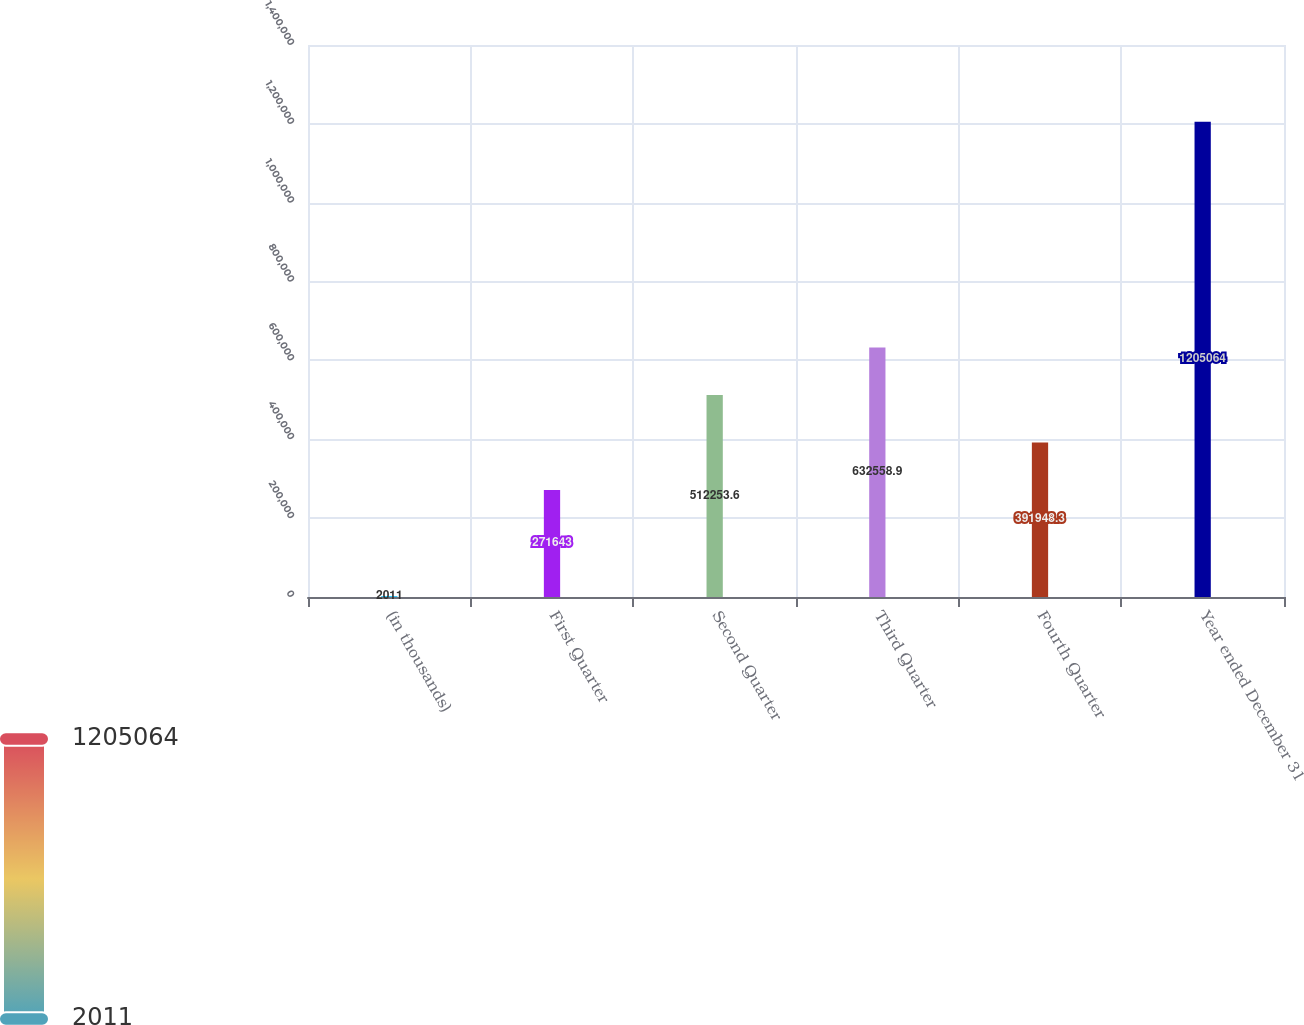<chart> <loc_0><loc_0><loc_500><loc_500><bar_chart><fcel>(in thousands)<fcel>First Quarter<fcel>Second Quarter<fcel>Third Quarter<fcel>Fourth Quarter<fcel>Year ended December 31<nl><fcel>2011<fcel>271643<fcel>512254<fcel>632559<fcel>391948<fcel>1.20506e+06<nl></chart> 